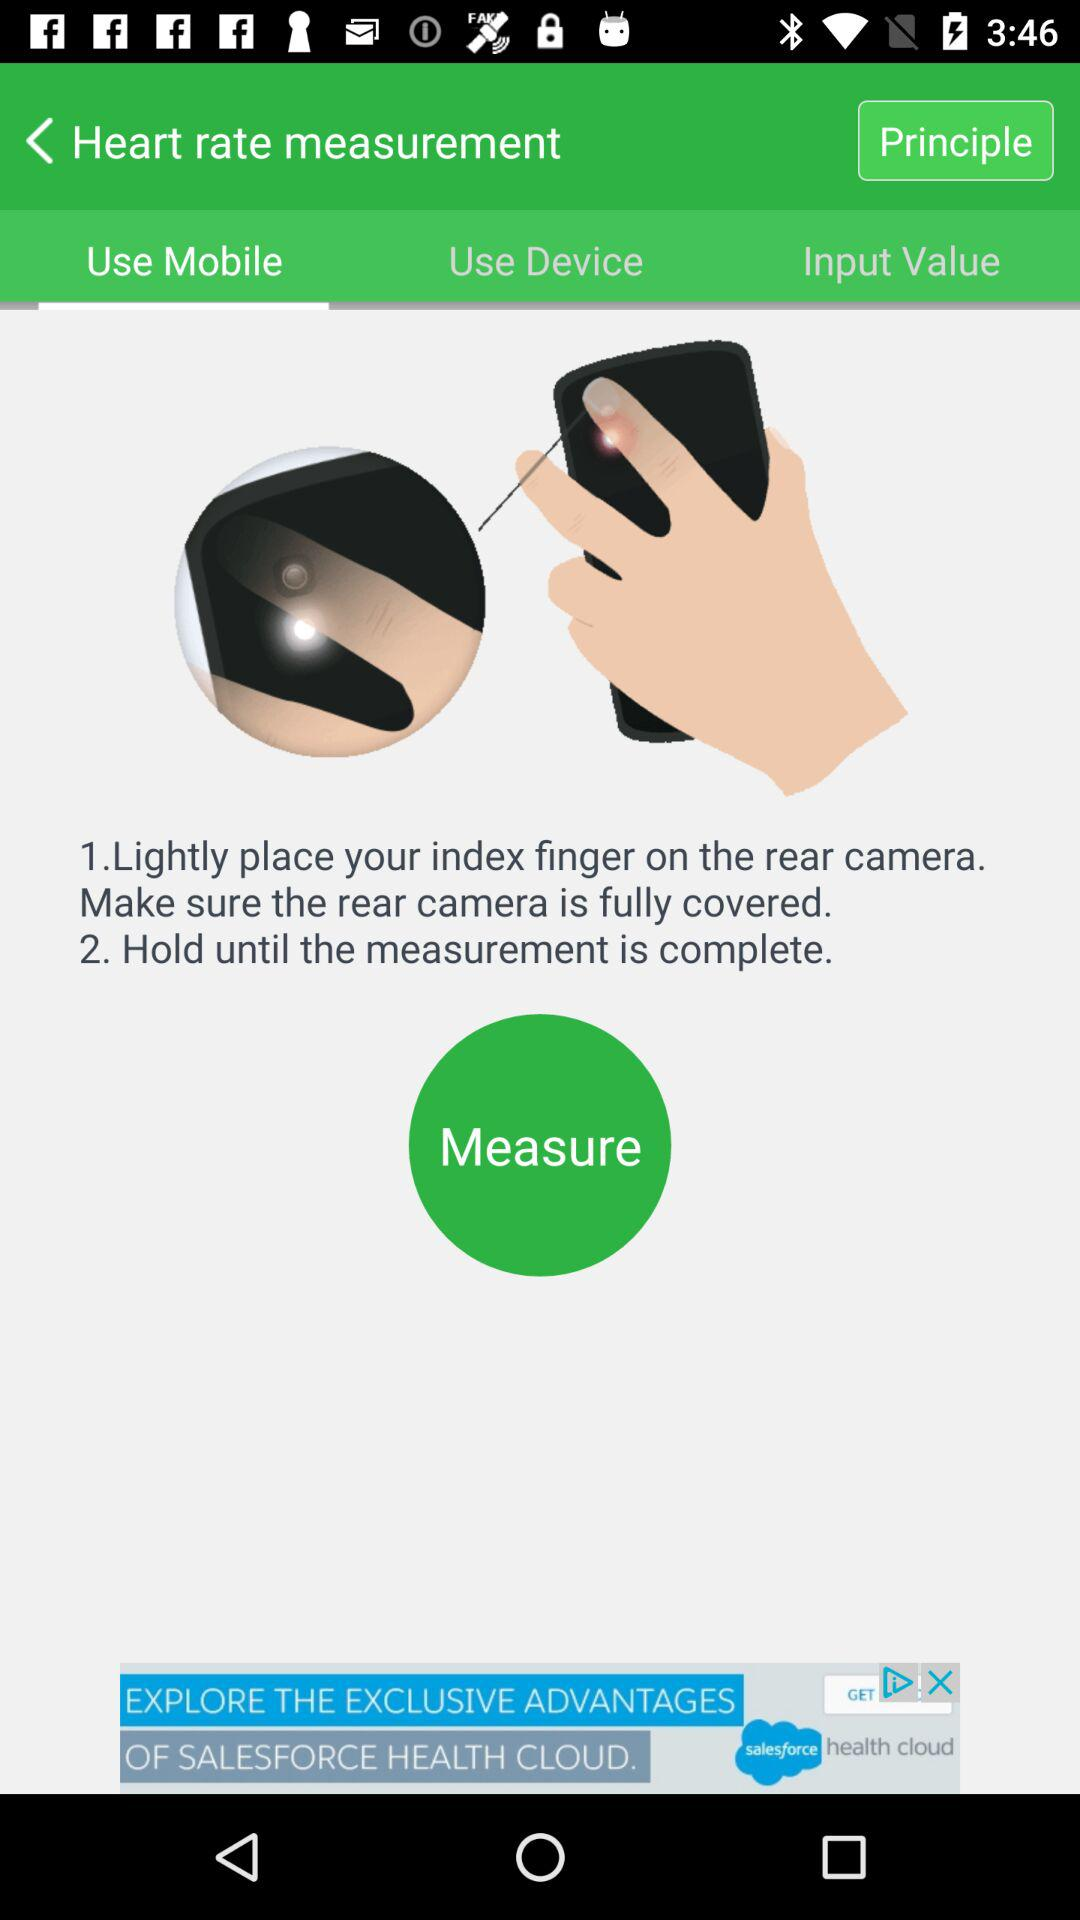Which tab is selected? The selected tab is "Use Mobile". 